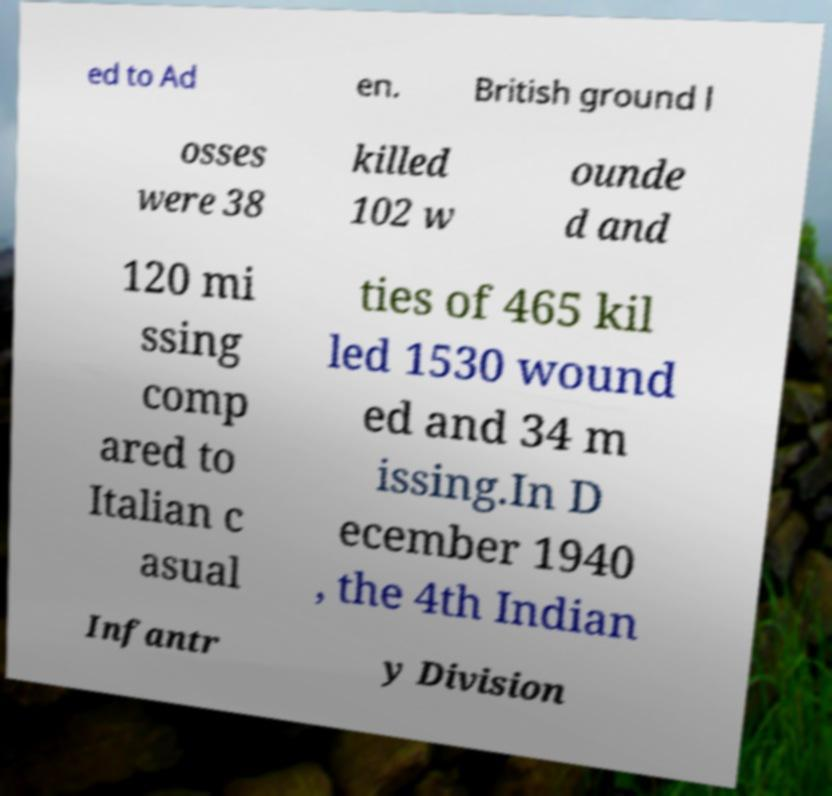I need the written content from this picture converted into text. Can you do that? ed to Ad en. British ground l osses were 38 killed 102 w ounde d and 120 mi ssing comp ared to Italian c asual ties of 465 kil led 1530 wound ed and 34 m issing.In D ecember 1940 , the 4th Indian Infantr y Division 